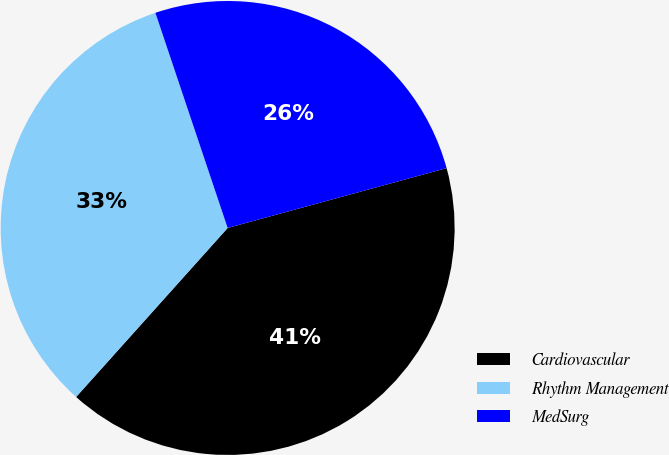Convert chart to OTSL. <chart><loc_0><loc_0><loc_500><loc_500><pie_chart><fcel>Cardiovascular<fcel>Rhythm Management<fcel>MedSurg<nl><fcel>40.88%<fcel>33.21%<fcel>25.91%<nl></chart> 